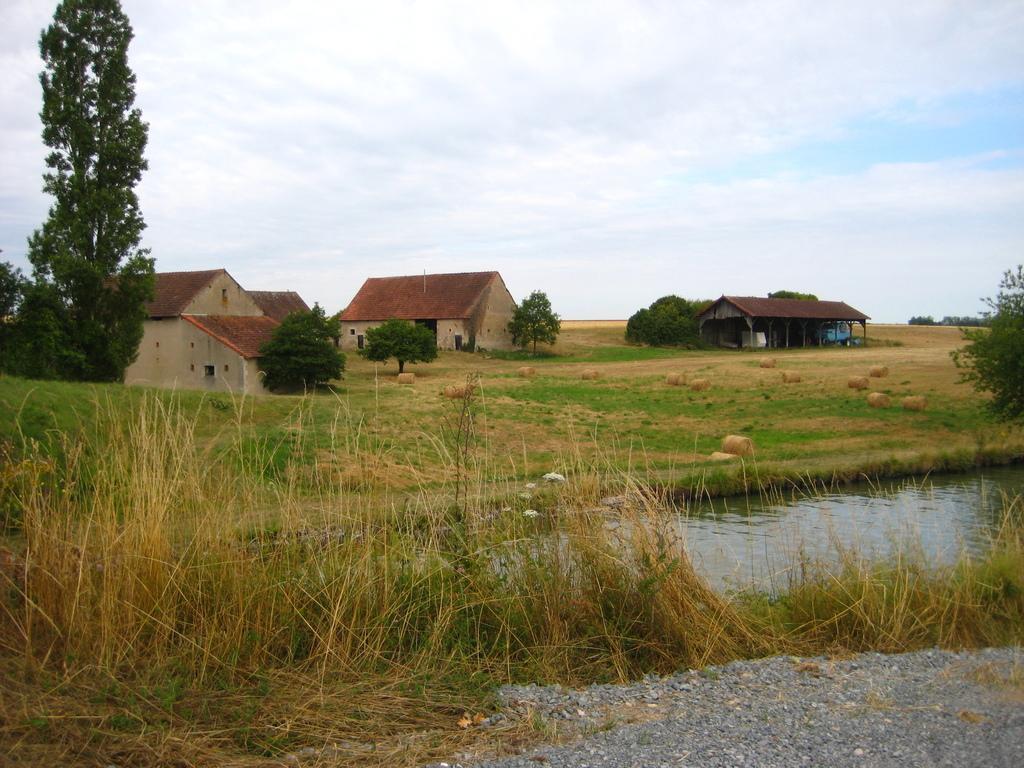In one or two sentences, can you explain what this image depicts? At the bottom we can see small stones, grass and water. In the background we can see trees, houses, roofs, vehicle and grass on the ground and we can see clouds in the sky. 